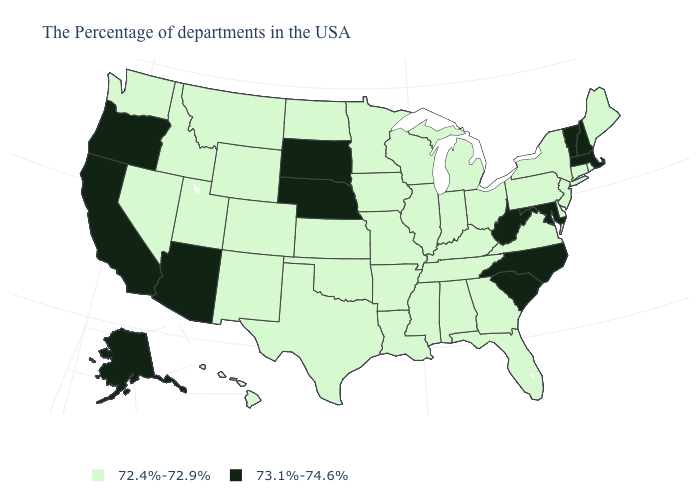What is the value of New Jersey?
Concise answer only. 72.4%-72.9%. What is the value of Arkansas?
Write a very short answer. 72.4%-72.9%. What is the highest value in the USA?
Short answer required. 73.1%-74.6%. What is the value of New Jersey?
Keep it brief. 72.4%-72.9%. What is the lowest value in states that border Utah?
Keep it brief. 72.4%-72.9%. Name the states that have a value in the range 73.1%-74.6%?
Write a very short answer. Massachusetts, New Hampshire, Vermont, Maryland, North Carolina, South Carolina, West Virginia, Nebraska, South Dakota, Arizona, California, Oregon, Alaska. Does Washington have a lower value than West Virginia?
Give a very brief answer. Yes. Name the states that have a value in the range 72.4%-72.9%?
Write a very short answer. Maine, Rhode Island, Connecticut, New York, New Jersey, Delaware, Pennsylvania, Virginia, Ohio, Florida, Georgia, Michigan, Kentucky, Indiana, Alabama, Tennessee, Wisconsin, Illinois, Mississippi, Louisiana, Missouri, Arkansas, Minnesota, Iowa, Kansas, Oklahoma, Texas, North Dakota, Wyoming, Colorado, New Mexico, Utah, Montana, Idaho, Nevada, Washington, Hawaii. Does Kentucky have a lower value than North Carolina?
Give a very brief answer. Yes. Name the states that have a value in the range 73.1%-74.6%?
Concise answer only. Massachusetts, New Hampshire, Vermont, Maryland, North Carolina, South Carolina, West Virginia, Nebraska, South Dakota, Arizona, California, Oregon, Alaska. Does Oregon have the highest value in the West?
Concise answer only. Yes. What is the lowest value in the USA?
Give a very brief answer. 72.4%-72.9%. Does California have a higher value than Arizona?
Be succinct. No. What is the value of Nevada?
Be succinct. 72.4%-72.9%. 